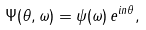Convert formula to latex. <formula><loc_0><loc_0><loc_500><loc_500>\Psi ( \theta , \omega ) = \psi ( \omega ) \, e ^ { i n \theta } ,</formula> 